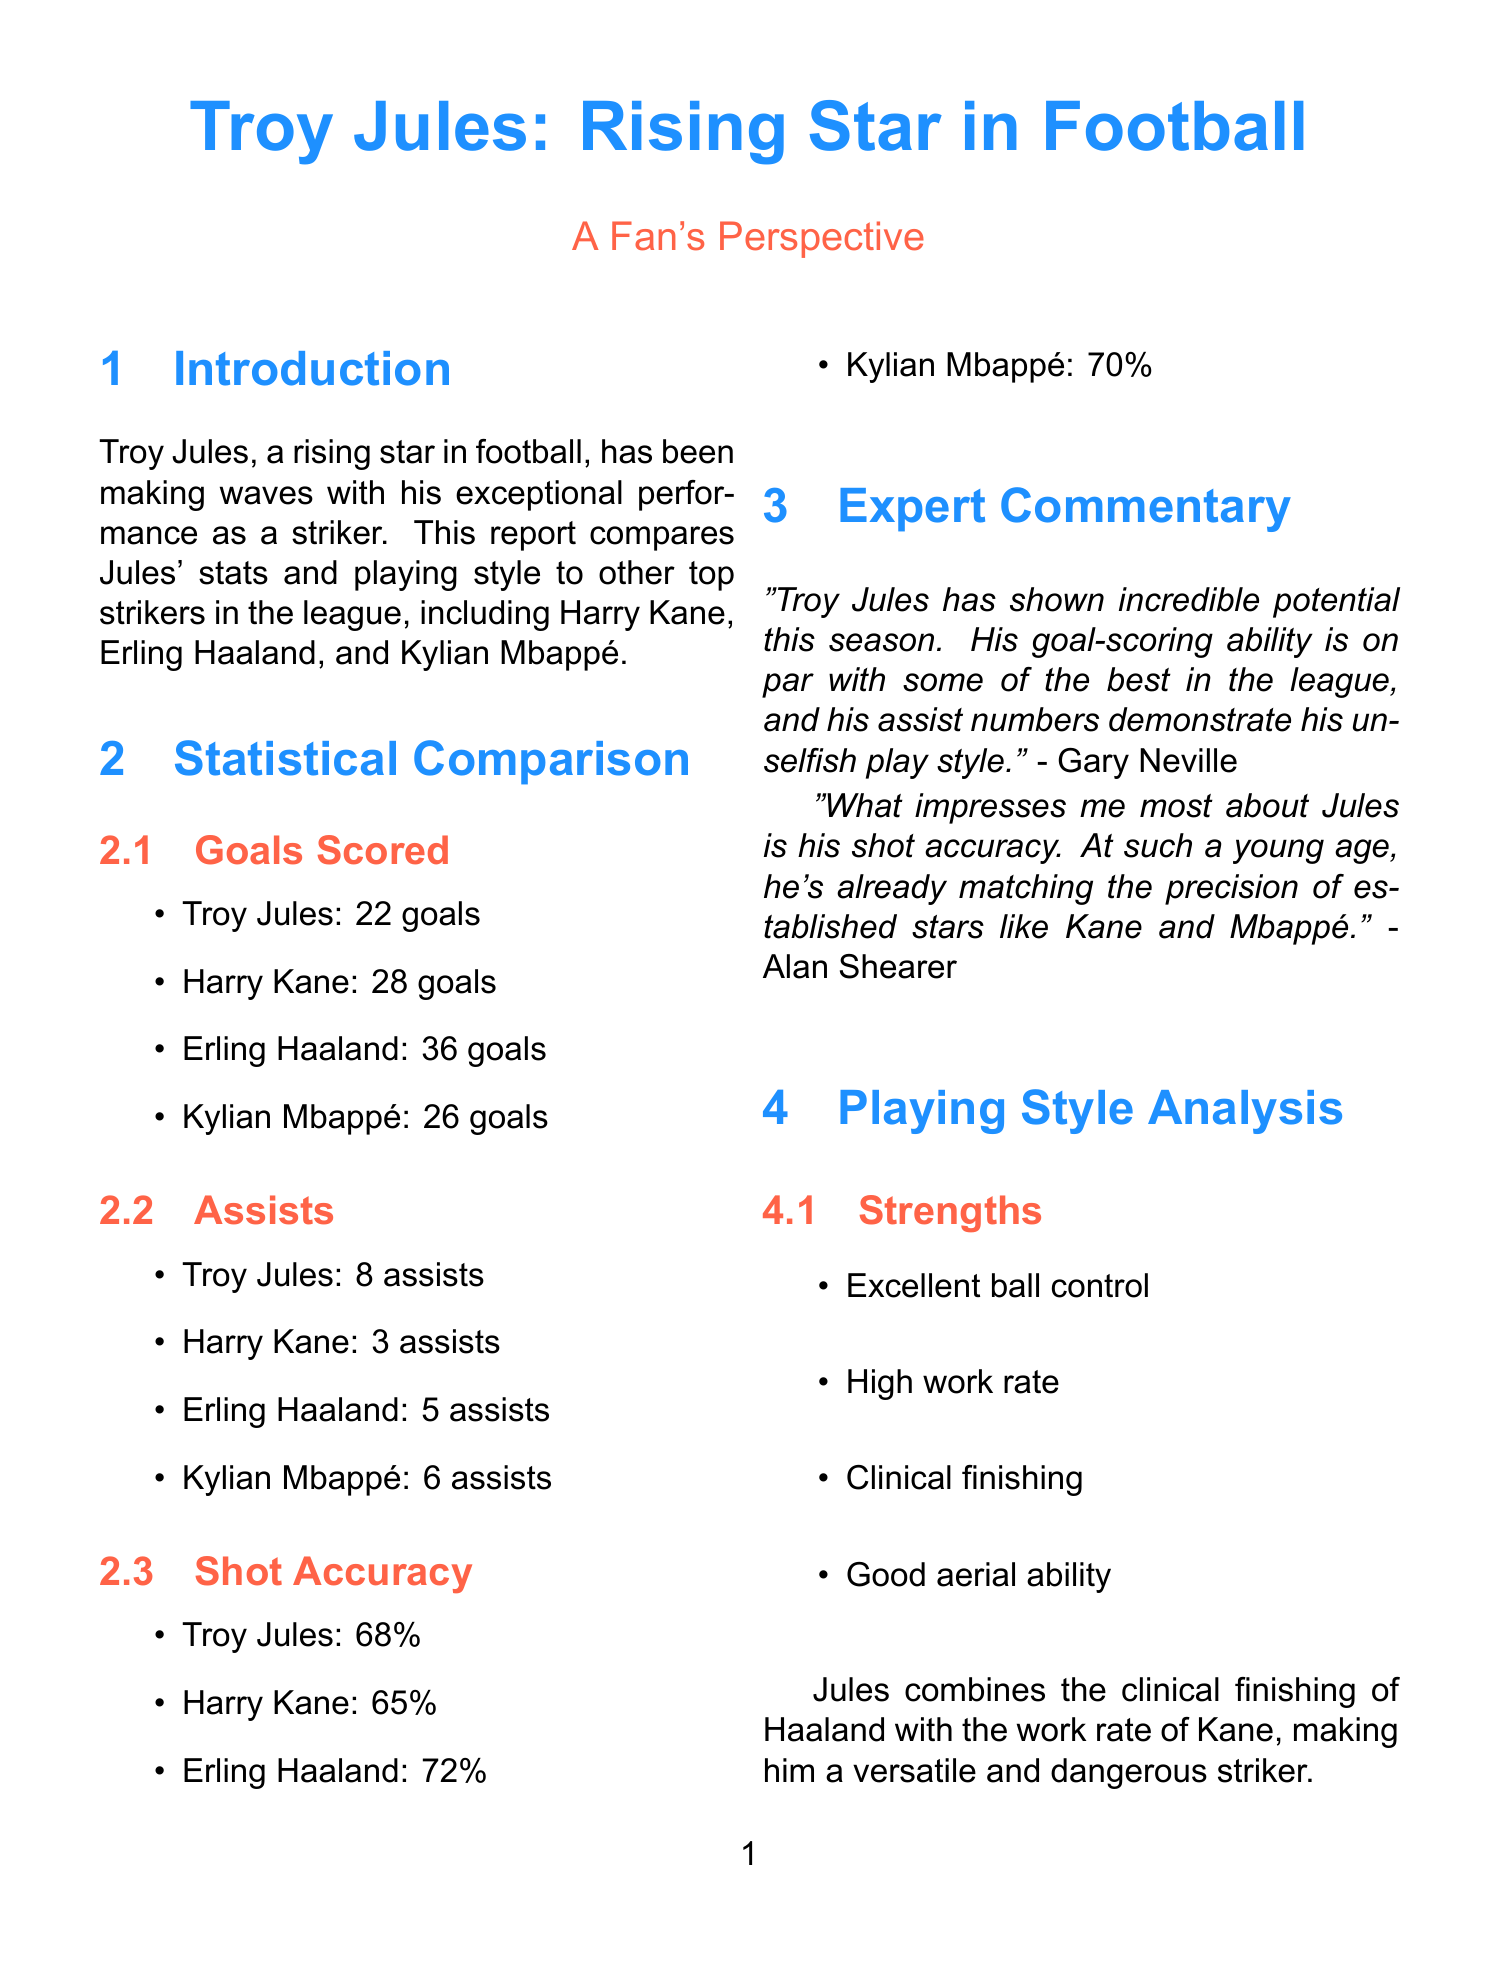what is the total number of goals scored by Troy Jules? The total number of goals scored by Troy Jules is given in the statistical comparison section.
Answer: 22 who are the key players compared to Troy Jules? The key players mentioned in the introduction are listed clearly.
Answer: Troy Jules, Harry Kane, Erling Haaland, Kylian Mbappé how many assists did Harry Kane log this season? Harry Kane's assists can be found in the assists section of the statistical comparison.
Answer: 3 which player has the highest shot accuracy? The shot accuracy percentages for each player are listed, making it easy to see who has the highest.
Answer: Erling Haaland what is the primary strength of Troy Jules mentioned in the report? The strengths of Troy Jules are listed, and one is particularly notable.
Answer: Clinical finishing how does Troy Jules' assist number compare to Erling Haaland's? The assists section provides a direct comparison of Troy Jules' and Erling Haaland's assist numbers.
Answer: Troy Jules has more assists which expert commented on Troy Jules' shot accuracy? The expert commentary section contains quotes from different experts, one focusing on shot accuracy.
Answer: Alan Shearer what does the fan Sarah say about Troy Jules? The fan perspective section features quotes from fans, including one from Sarah.
Answer: "Troy Jules is my idol!" 